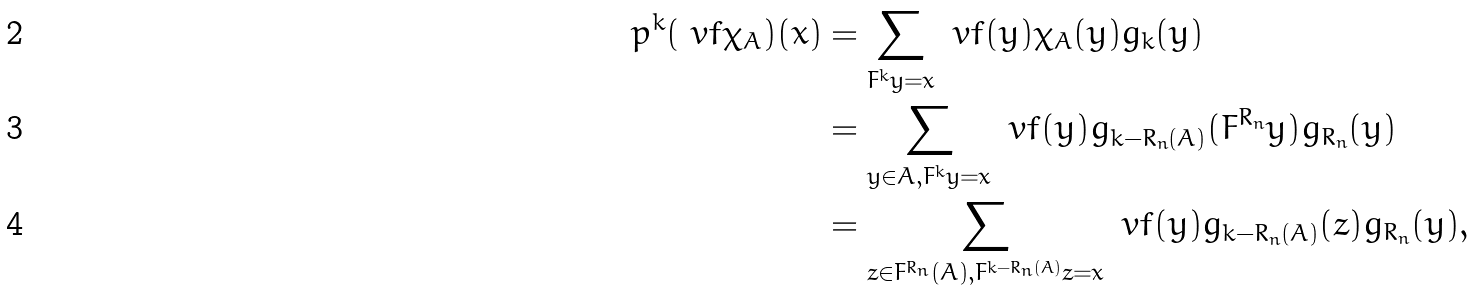<formula> <loc_0><loc_0><loc_500><loc_500>\L p ^ { k } ( \ v f \chi _ { A } ) ( x ) & = \sum _ { F ^ { k } y = x } \ v f ( y ) \chi _ { A } ( y ) g _ { k } ( y ) \\ & = \sum _ { y \in A , F ^ { k } y = x } \ v f ( y ) g _ { k - R _ { n } ( A ) } ( F ^ { R _ { n } } y ) g _ { R _ { n } } ( y ) \\ & = \sum _ { z \in F ^ { R _ { n } } ( A ) , F ^ { k - R _ { n } ( A ) } z = x } \ v f ( y ) g _ { k - R _ { n } ( A ) } ( z ) g _ { R _ { n } } ( y ) ,</formula> 